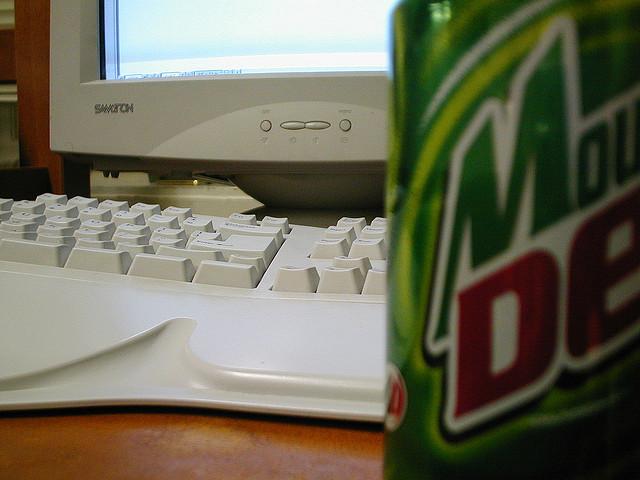Is this a computer?
Give a very brief answer. Yes. What is the object in front of the keyboard?
Be succinct. Soda can. Is there a caffeine source in the picture?
Answer briefly. Yes. What type of soft drink bottle is this?
Be succinct. Mountain dew. Is this a laptop?
Quick response, please. No. 